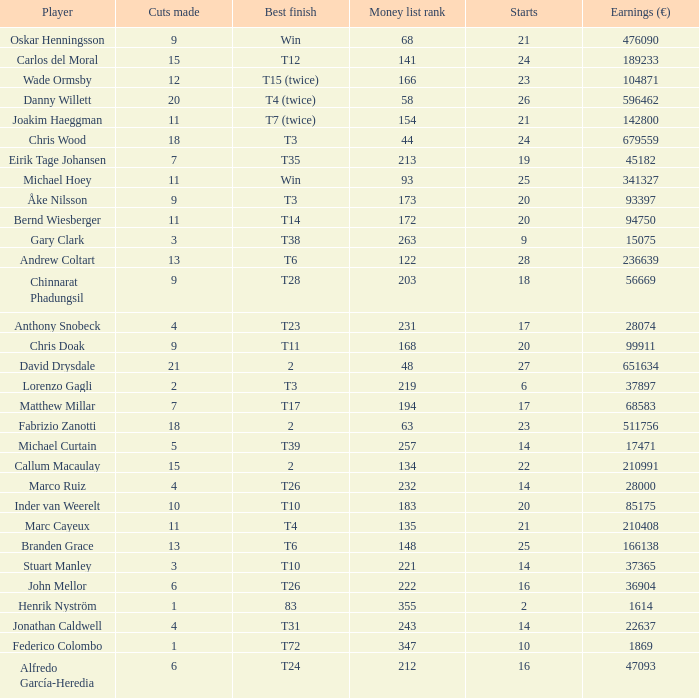Which player made exactly 26 starts? Danny Willett. Could you help me parse every detail presented in this table? {'header': ['Player', 'Cuts made', 'Best finish', 'Money list rank', 'Starts', 'Earnings (€)'], 'rows': [['Oskar Henningsson', '9', 'Win', '68', '21', '476090'], ['Carlos del Moral', '15', 'T12', '141', '24', '189233'], ['Wade Ormsby', '12', 'T15 (twice)', '166', '23', '104871'], ['Danny Willett', '20', 'T4 (twice)', '58', '26', '596462'], ['Joakim Haeggman', '11', 'T7 (twice)', '154', '21', '142800'], ['Chris Wood', '18', 'T3', '44', '24', '679559'], ['Eirik Tage Johansen', '7', 'T35', '213', '19', '45182'], ['Michael Hoey', '11', 'Win', '93', '25', '341327'], ['Åke Nilsson', '9', 'T3', '173', '20', '93397'], ['Bernd Wiesberger', '11', 'T14', '172', '20', '94750'], ['Gary Clark', '3', 'T38', '263', '9', '15075'], ['Andrew Coltart', '13', 'T6', '122', '28', '236639'], ['Chinnarat Phadungsil', '9', 'T28', '203', '18', '56669'], ['Anthony Snobeck', '4', 'T23', '231', '17', '28074'], ['Chris Doak', '9', 'T11', '168', '20', '99911'], ['David Drysdale', '21', '2', '48', '27', '651634'], ['Lorenzo Gagli', '2', 'T3', '219', '6', '37897'], ['Matthew Millar', '7', 'T17', '194', '17', '68583'], ['Fabrizio Zanotti', '18', '2', '63', '23', '511756'], ['Michael Curtain', '5', 'T39', '257', '14', '17471'], ['Callum Macaulay', '15', '2', '134', '22', '210991'], ['Marco Ruiz', '4', 'T26', '232', '14', '28000'], ['Inder van Weerelt', '10', 'T10', '183', '20', '85175'], ['Marc Cayeux', '11', 'T4', '135', '21', '210408'], ['Branden Grace', '13', 'T6', '148', '25', '166138'], ['Stuart Manley', '3', 'T10', '221', '14', '37365'], ['John Mellor', '6', 'T26', '222', '16', '36904'], ['Henrik Nyström', '1', '83', '355', '2', '1614'], ['Jonathan Caldwell', '4', 'T31', '243', '14', '22637'], ['Federico Colombo', '1', 'T72', '347', '10', '1869'], ['Alfredo García-Heredia', '6', 'T24', '212', '16', '47093']]} 